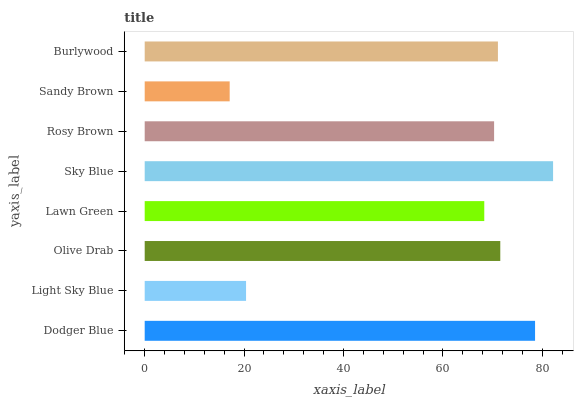Is Sandy Brown the minimum?
Answer yes or no. Yes. Is Sky Blue the maximum?
Answer yes or no. Yes. Is Light Sky Blue the minimum?
Answer yes or no. No. Is Light Sky Blue the maximum?
Answer yes or no. No. Is Dodger Blue greater than Light Sky Blue?
Answer yes or no. Yes. Is Light Sky Blue less than Dodger Blue?
Answer yes or no. Yes. Is Light Sky Blue greater than Dodger Blue?
Answer yes or no. No. Is Dodger Blue less than Light Sky Blue?
Answer yes or no. No. Is Burlywood the high median?
Answer yes or no. Yes. Is Rosy Brown the low median?
Answer yes or no. Yes. Is Rosy Brown the high median?
Answer yes or no. No. Is Olive Drab the low median?
Answer yes or no. No. 